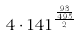Convert formula to latex. <formula><loc_0><loc_0><loc_500><loc_500>4 \cdot 1 4 1 ^ { \frac { \frac { 9 3 } { 4 9 5 } } { 2 } }</formula> 